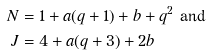Convert formula to latex. <formula><loc_0><loc_0><loc_500><loc_500>N & = 1 + a ( q + 1 ) + b + q ^ { 2 } \text { and } \\ J & = 4 + a ( q + 3 ) + 2 b</formula> 